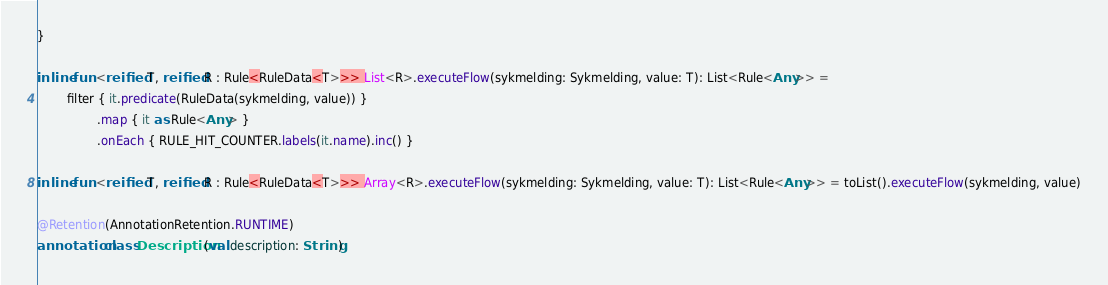<code> <loc_0><loc_0><loc_500><loc_500><_Kotlin_>}

inline fun <reified T, reified R : Rule<RuleData<T>>> List<R>.executeFlow(sykmelding: Sykmelding, value: T): List<Rule<Any>> =
        filter { it.predicate(RuleData(sykmelding, value)) }
                .map { it as Rule<Any> }
                .onEach { RULE_HIT_COUNTER.labels(it.name).inc() }

inline fun <reified T, reified R : Rule<RuleData<T>>> Array<R>.executeFlow(sykmelding: Sykmelding, value: T): List<Rule<Any>> = toList().executeFlow(sykmelding, value)

@Retention(AnnotationRetention.RUNTIME)
annotation class Description(val description: String)
</code> 